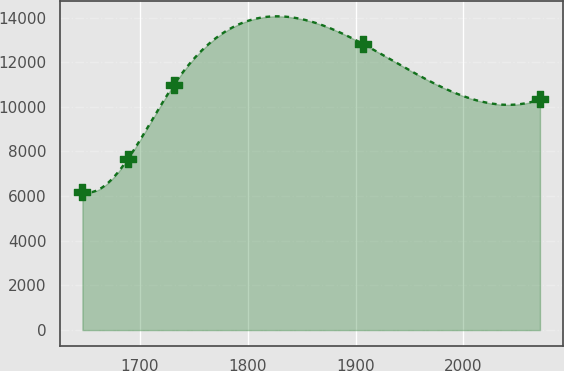Convert chart to OTSL. <chart><loc_0><loc_0><loc_500><loc_500><line_chart><ecel><fcel>Unnamed: 1<nl><fcel>1646.88<fcel>6201.67<nl><fcel>1689.29<fcel>7683.97<nl><fcel>1731.7<fcel>10995.2<nl><fcel>1906.93<fcel>12816.1<nl><fcel>2070.97<fcel>10333.7<nl></chart> 